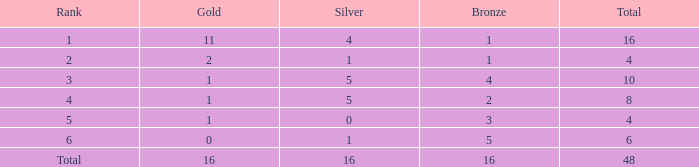How many gold are a tier 1 and bigger than 16? 0.0. 